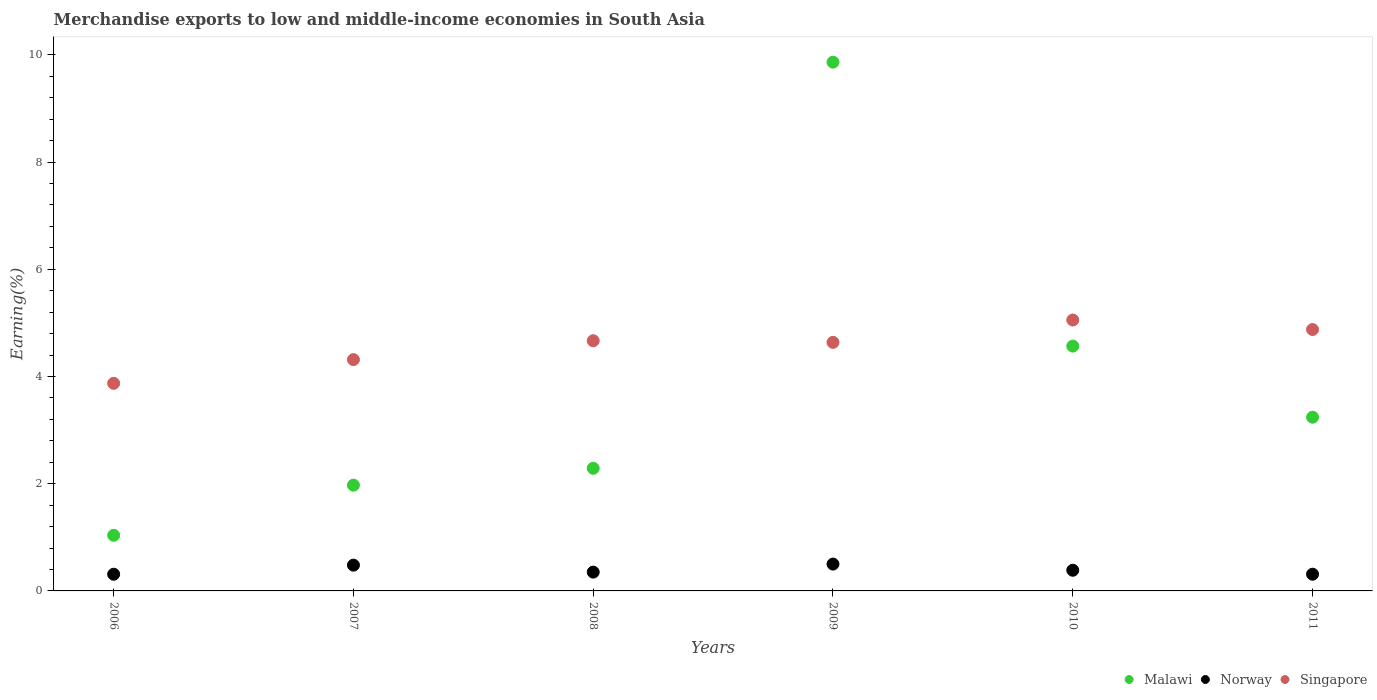How many different coloured dotlines are there?
Offer a terse response. 3. Is the number of dotlines equal to the number of legend labels?
Give a very brief answer. Yes. What is the percentage of amount earned from merchandise exports in Norway in 2008?
Offer a very short reply. 0.35. Across all years, what is the maximum percentage of amount earned from merchandise exports in Malawi?
Offer a very short reply. 9.86. Across all years, what is the minimum percentage of amount earned from merchandise exports in Malawi?
Give a very brief answer. 1.04. In which year was the percentage of amount earned from merchandise exports in Norway maximum?
Keep it short and to the point. 2009. In which year was the percentage of amount earned from merchandise exports in Malawi minimum?
Your answer should be compact. 2006. What is the total percentage of amount earned from merchandise exports in Singapore in the graph?
Provide a short and direct response. 27.42. What is the difference between the percentage of amount earned from merchandise exports in Malawi in 2006 and that in 2007?
Ensure brevity in your answer.  -0.94. What is the difference between the percentage of amount earned from merchandise exports in Malawi in 2009 and the percentage of amount earned from merchandise exports in Singapore in 2007?
Provide a short and direct response. 5.55. What is the average percentage of amount earned from merchandise exports in Norway per year?
Offer a terse response. 0.39. In the year 2006, what is the difference between the percentage of amount earned from merchandise exports in Singapore and percentage of amount earned from merchandise exports in Malawi?
Your answer should be compact. 2.83. What is the ratio of the percentage of amount earned from merchandise exports in Singapore in 2007 to that in 2009?
Provide a succinct answer. 0.93. Is the difference between the percentage of amount earned from merchandise exports in Singapore in 2010 and 2011 greater than the difference between the percentage of amount earned from merchandise exports in Malawi in 2010 and 2011?
Your answer should be very brief. No. What is the difference between the highest and the second highest percentage of amount earned from merchandise exports in Norway?
Your answer should be very brief. 0.02. What is the difference between the highest and the lowest percentage of amount earned from merchandise exports in Norway?
Ensure brevity in your answer.  0.19. Is the sum of the percentage of amount earned from merchandise exports in Singapore in 2007 and 2008 greater than the maximum percentage of amount earned from merchandise exports in Norway across all years?
Offer a very short reply. Yes. Is the percentage of amount earned from merchandise exports in Norway strictly greater than the percentage of amount earned from merchandise exports in Malawi over the years?
Keep it short and to the point. No. Is the percentage of amount earned from merchandise exports in Singapore strictly less than the percentage of amount earned from merchandise exports in Norway over the years?
Ensure brevity in your answer.  No. How many years are there in the graph?
Provide a short and direct response. 6. Does the graph contain grids?
Make the answer very short. No. Where does the legend appear in the graph?
Your answer should be very brief. Bottom right. What is the title of the graph?
Provide a succinct answer. Merchandise exports to low and middle-income economies in South Asia. Does "Liberia" appear as one of the legend labels in the graph?
Your response must be concise. No. What is the label or title of the X-axis?
Your answer should be compact. Years. What is the label or title of the Y-axis?
Provide a succinct answer. Earning(%). What is the Earning(%) of Malawi in 2006?
Your answer should be compact. 1.04. What is the Earning(%) of Norway in 2006?
Your response must be concise. 0.31. What is the Earning(%) of Singapore in 2006?
Your response must be concise. 3.87. What is the Earning(%) of Malawi in 2007?
Your answer should be very brief. 1.97. What is the Earning(%) in Norway in 2007?
Offer a very short reply. 0.48. What is the Earning(%) of Singapore in 2007?
Make the answer very short. 4.31. What is the Earning(%) in Malawi in 2008?
Ensure brevity in your answer.  2.29. What is the Earning(%) of Norway in 2008?
Provide a succinct answer. 0.35. What is the Earning(%) of Singapore in 2008?
Make the answer very short. 4.67. What is the Earning(%) of Malawi in 2009?
Provide a succinct answer. 9.86. What is the Earning(%) in Norway in 2009?
Ensure brevity in your answer.  0.5. What is the Earning(%) in Singapore in 2009?
Provide a short and direct response. 4.64. What is the Earning(%) in Malawi in 2010?
Offer a very short reply. 4.57. What is the Earning(%) of Norway in 2010?
Offer a very short reply. 0.39. What is the Earning(%) in Singapore in 2010?
Provide a short and direct response. 5.05. What is the Earning(%) in Malawi in 2011?
Your response must be concise. 3.24. What is the Earning(%) in Norway in 2011?
Your answer should be compact. 0.31. What is the Earning(%) of Singapore in 2011?
Your answer should be compact. 4.88. Across all years, what is the maximum Earning(%) in Malawi?
Ensure brevity in your answer.  9.86. Across all years, what is the maximum Earning(%) of Norway?
Offer a terse response. 0.5. Across all years, what is the maximum Earning(%) in Singapore?
Offer a very short reply. 5.05. Across all years, what is the minimum Earning(%) of Malawi?
Your answer should be compact. 1.04. Across all years, what is the minimum Earning(%) of Norway?
Ensure brevity in your answer.  0.31. Across all years, what is the minimum Earning(%) of Singapore?
Provide a succinct answer. 3.87. What is the total Earning(%) of Malawi in the graph?
Give a very brief answer. 22.97. What is the total Earning(%) of Norway in the graph?
Your response must be concise. 2.34. What is the total Earning(%) in Singapore in the graph?
Make the answer very short. 27.42. What is the difference between the Earning(%) of Malawi in 2006 and that in 2007?
Make the answer very short. -0.94. What is the difference between the Earning(%) of Norway in 2006 and that in 2007?
Ensure brevity in your answer.  -0.17. What is the difference between the Earning(%) in Singapore in 2006 and that in 2007?
Your answer should be very brief. -0.44. What is the difference between the Earning(%) in Malawi in 2006 and that in 2008?
Your answer should be compact. -1.25. What is the difference between the Earning(%) of Norway in 2006 and that in 2008?
Your response must be concise. -0.04. What is the difference between the Earning(%) of Singapore in 2006 and that in 2008?
Your answer should be compact. -0.79. What is the difference between the Earning(%) in Malawi in 2006 and that in 2009?
Provide a succinct answer. -8.82. What is the difference between the Earning(%) of Norway in 2006 and that in 2009?
Offer a terse response. -0.19. What is the difference between the Earning(%) in Singapore in 2006 and that in 2009?
Provide a short and direct response. -0.76. What is the difference between the Earning(%) of Malawi in 2006 and that in 2010?
Your answer should be very brief. -3.53. What is the difference between the Earning(%) in Norway in 2006 and that in 2010?
Provide a succinct answer. -0.07. What is the difference between the Earning(%) in Singapore in 2006 and that in 2010?
Ensure brevity in your answer.  -1.18. What is the difference between the Earning(%) in Malawi in 2006 and that in 2011?
Offer a terse response. -2.2. What is the difference between the Earning(%) in Norway in 2006 and that in 2011?
Keep it short and to the point. -0. What is the difference between the Earning(%) of Singapore in 2006 and that in 2011?
Your answer should be very brief. -1. What is the difference between the Earning(%) in Malawi in 2007 and that in 2008?
Offer a very short reply. -0.31. What is the difference between the Earning(%) in Norway in 2007 and that in 2008?
Give a very brief answer. 0.13. What is the difference between the Earning(%) in Singapore in 2007 and that in 2008?
Your answer should be very brief. -0.35. What is the difference between the Earning(%) in Malawi in 2007 and that in 2009?
Offer a very short reply. -7.89. What is the difference between the Earning(%) in Norway in 2007 and that in 2009?
Keep it short and to the point. -0.02. What is the difference between the Earning(%) in Singapore in 2007 and that in 2009?
Keep it short and to the point. -0.32. What is the difference between the Earning(%) of Malawi in 2007 and that in 2010?
Your answer should be very brief. -2.59. What is the difference between the Earning(%) in Norway in 2007 and that in 2010?
Offer a very short reply. 0.1. What is the difference between the Earning(%) of Singapore in 2007 and that in 2010?
Provide a succinct answer. -0.74. What is the difference between the Earning(%) in Malawi in 2007 and that in 2011?
Your answer should be very brief. -1.27. What is the difference between the Earning(%) of Norway in 2007 and that in 2011?
Your answer should be very brief. 0.17. What is the difference between the Earning(%) of Singapore in 2007 and that in 2011?
Make the answer very short. -0.56. What is the difference between the Earning(%) of Malawi in 2008 and that in 2009?
Provide a short and direct response. -7.57. What is the difference between the Earning(%) of Norway in 2008 and that in 2009?
Make the answer very short. -0.15. What is the difference between the Earning(%) in Singapore in 2008 and that in 2009?
Offer a very short reply. 0.03. What is the difference between the Earning(%) in Malawi in 2008 and that in 2010?
Provide a short and direct response. -2.28. What is the difference between the Earning(%) in Norway in 2008 and that in 2010?
Keep it short and to the point. -0.03. What is the difference between the Earning(%) of Singapore in 2008 and that in 2010?
Give a very brief answer. -0.39. What is the difference between the Earning(%) in Malawi in 2008 and that in 2011?
Your answer should be compact. -0.95. What is the difference between the Earning(%) of Norway in 2008 and that in 2011?
Your response must be concise. 0.04. What is the difference between the Earning(%) in Singapore in 2008 and that in 2011?
Offer a terse response. -0.21. What is the difference between the Earning(%) of Malawi in 2009 and that in 2010?
Offer a very short reply. 5.3. What is the difference between the Earning(%) in Norway in 2009 and that in 2010?
Offer a terse response. 0.12. What is the difference between the Earning(%) of Singapore in 2009 and that in 2010?
Provide a short and direct response. -0.42. What is the difference between the Earning(%) in Malawi in 2009 and that in 2011?
Keep it short and to the point. 6.62. What is the difference between the Earning(%) in Norway in 2009 and that in 2011?
Provide a short and direct response. 0.19. What is the difference between the Earning(%) of Singapore in 2009 and that in 2011?
Your answer should be compact. -0.24. What is the difference between the Earning(%) in Malawi in 2010 and that in 2011?
Offer a terse response. 1.33. What is the difference between the Earning(%) in Norway in 2010 and that in 2011?
Offer a terse response. 0.07. What is the difference between the Earning(%) of Singapore in 2010 and that in 2011?
Your answer should be very brief. 0.18. What is the difference between the Earning(%) of Malawi in 2006 and the Earning(%) of Norway in 2007?
Provide a succinct answer. 0.56. What is the difference between the Earning(%) in Malawi in 2006 and the Earning(%) in Singapore in 2007?
Your answer should be compact. -3.28. What is the difference between the Earning(%) in Norway in 2006 and the Earning(%) in Singapore in 2007?
Make the answer very short. -4. What is the difference between the Earning(%) of Malawi in 2006 and the Earning(%) of Norway in 2008?
Provide a short and direct response. 0.69. What is the difference between the Earning(%) of Malawi in 2006 and the Earning(%) of Singapore in 2008?
Keep it short and to the point. -3.63. What is the difference between the Earning(%) of Norway in 2006 and the Earning(%) of Singapore in 2008?
Your answer should be compact. -4.36. What is the difference between the Earning(%) in Malawi in 2006 and the Earning(%) in Norway in 2009?
Keep it short and to the point. 0.54. What is the difference between the Earning(%) in Malawi in 2006 and the Earning(%) in Singapore in 2009?
Make the answer very short. -3.6. What is the difference between the Earning(%) of Norway in 2006 and the Earning(%) of Singapore in 2009?
Ensure brevity in your answer.  -4.32. What is the difference between the Earning(%) in Malawi in 2006 and the Earning(%) in Norway in 2010?
Offer a terse response. 0.65. What is the difference between the Earning(%) in Malawi in 2006 and the Earning(%) in Singapore in 2010?
Offer a terse response. -4.02. What is the difference between the Earning(%) of Norway in 2006 and the Earning(%) of Singapore in 2010?
Make the answer very short. -4.74. What is the difference between the Earning(%) in Malawi in 2006 and the Earning(%) in Norway in 2011?
Keep it short and to the point. 0.73. What is the difference between the Earning(%) in Malawi in 2006 and the Earning(%) in Singapore in 2011?
Your answer should be very brief. -3.84. What is the difference between the Earning(%) in Norway in 2006 and the Earning(%) in Singapore in 2011?
Provide a short and direct response. -4.56. What is the difference between the Earning(%) in Malawi in 2007 and the Earning(%) in Norway in 2008?
Ensure brevity in your answer.  1.62. What is the difference between the Earning(%) in Malawi in 2007 and the Earning(%) in Singapore in 2008?
Your answer should be compact. -2.69. What is the difference between the Earning(%) of Norway in 2007 and the Earning(%) of Singapore in 2008?
Your answer should be very brief. -4.19. What is the difference between the Earning(%) of Malawi in 2007 and the Earning(%) of Norway in 2009?
Make the answer very short. 1.47. What is the difference between the Earning(%) in Malawi in 2007 and the Earning(%) in Singapore in 2009?
Ensure brevity in your answer.  -2.66. What is the difference between the Earning(%) of Norway in 2007 and the Earning(%) of Singapore in 2009?
Make the answer very short. -4.16. What is the difference between the Earning(%) of Malawi in 2007 and the Earning(%) of Norway in 2010?
Your answer should be very brief. 1.59. What is the difference between the Earning(%) of Malawi in 2007 and the Earning(%) of Singapore in 2010?
Your answer should be compact. -3.08. What is the difference between the Earning(%) in Norway in 2007 and the Earning(%) in Singapore in 2010?
Provide a short and direct response. -4.57. What is the difference between the Earning(%) in Malawi in 2007 and the Earning(%) in Norway in 2011?
Make the answer very short. 1.66. What is the difference between the Earning(%) of Malawi in 2007 and the Earning(%) of Singapore in 2011?
Ensure brevity in your answer.  -2.9. What is the difference between the Earning(%) in Norway in 2007 and the Earning(%) in Singapore in 2011?
Make the answer very short. -4.39. What is the difference between the Earning(%) in Malawi in 2008 and the Earning(%) in Norway in 2009?
Offer a very short reply. 1.79. What is the difference between the Earning(%) in Malawi in 2008 and the Earning(%) in Singapore in 2009?
Give a very brief answer. -2.35. What is the difference between the Earning(%) of Norway in 2008 and the Earning(%) of Singapore in 2009?
Provide a succinct answer. -4.29. What is the difference between the Earning(%) in Malawi in 2008 and the Earning(%) in Norway in 2010?
Ensure brevity in your answer.  1.9. What is the difference between the Earning(%) in Malawi in 2008 and the Earning(%) in Singapore in 2010?
Keep it short and to the point. -2.77. What is the difference between the Earning(%) in Norway in 2008 and the Earning(%) in Singapore in 2010?
Keep it short and to the point. -4.7. What is the difference between the Earning(%) in Malawi in 2008 and the Earning(%) in Norway in 2011?
Provide a short and direct response. 1.98. What is the difference between the Earning(%) in Malawi in 2008 and the Earning(%) in Singapore in 2011?
Offer a very short reply. -2.59. What is the difference between the Earning(%) in Norway in 2008 and the Earning(%) in Singapore in 2011?
Your answer should be compact. -4.52. What is the difference between the Earning(%) in Malawi in 2009 and the Earning(%) in Norway in 2010?
Your answer should be compact. 9.48. What is the difference between the Earning(%) in Malawi in 2009 and the Earning(%) in Singapore in 2010?
Your answer should be compact. 4.81. What is the difference between the Earning(%) in Norway in 2009 and the Earning(%) in Singapore in 2010?
Make the answer very short. -4.55. What is the difference between the Earning(%) of Malawi in 2009 and the Earning(%) of Norway in 2011?
Your response must be concise. 9.55. What is the difference between the Earning(%) in Malawi in 2009 and the Earning(%) in Singapore in 2011?
Offer a very short reply. 4.99. What is the difference between the Earning(%) of Norway in 2009 and the Earning(%) of Singapore in 2011?
Provide a succinct answer. -4.37. What is the difference between the Earning(%) in Malawi in 2010 and the Earning(%) in Norway in 2011?
Your answer should be very brief. 4.25. What is the difference between the Earning(%) of Malawi in 2010 and the Earning(%) of Singapore in 2011?
Ensure brevity in your answer.  -0.31. What is the difference between the Earning(%) in Norway in 2010 and the Earning(%) in Singapore in 2011?
Offer a very short reply. -4.49. What is the average Earning(%) of Malawi per year?
Offer a terse response. 3.83. What is the average Earning(%) of Norway per year?
Make the answer very short. 0.39. What is the average Earning(%) of Singapore per year?
Provide a short and direct response. 4.57. In the year 2006, what is the difference between the Earning(%) in Malawi and Earning(%) in Norway?
Offer a very short reply. 0.73. In the year 2006, what is the difference between the Earning(%) of Malawi and Earning(%) of Singapore?
Keep it short and to the point. -2.83. In the year 2006, what is the difference between the Earning(%) in Norway and Earning(%) in Singapore?
Your answer should be very brief. -3.56. In the year 2007, what is the difference between the Earning(%) of Malawi and Earning(%) of Norway?
Your answer should be very brief. 1.49. In the year 2007, what is the difference between the Earning(%) in Malawi and Earning(%) in Singapore?
Your answer should be compact. -2.34. In the year 2007, what is the difference between the Earning(%) in Norway and Earning(%) in Singapore?
Your response must be concise. -3.83. In the year 2008, what is the difference between the Earning(%) of Malawi and Earning(%) of Norway?
Make the answer very short. 1.94. In the year 2008, what is the difference between the Earning(%) in Malawi and Earning(%) in Singapore?
Give a very brief answer. -2.38. In the year 2008, what is the difference between the Earning(%) in Norway and Earning(%) in Singapore?
Ensure brevity in your answer.  -4.32. In the year 2009, what is the difference between the Earning(%) in Malawi and Earning(%) in Norway?
Offer a very short reply. 9.36. In the year 2009, what is the difference between the Earning(%) of Malawi and Earning(%) of Singapore?
Keep it short and to the point. 5.23. In the year 2009, what is the difference between the Earning(%) in Norway and Earning(%) in Singapore?
Give a very brief answer. -4.14. In the year 2010, what is the difference between the Earning(%) of Malawi and Earning(%) of Norway?
Your answer should be compact. 4.18. In the year 2010, what is the difference between the Earning(%) of Malawi and Earning(%) of Singapore?
Your response must be concise. -0.49. In the year 2010, what is the difference between the Earning(%) in Norway and Earning(%) in Singapore?
Offer a very short reply. -4.67. In the year 2011, what is the difference between the Earning(%) of Malawi and Earning(%) of Norway?
Offer a very short reply. 2.93. In the year 2011, what is the difference between the Earning(%) of Malawi and Earning(%) of Singapore?
Provide a succinct answer. -1.64. In the year 2011, what is the difference between the Earning(%) in Norway and Earning(%) in Singapore?
Keep it short and to the point. -4.56. What is the ratio of the Earning(%) in Malawi in 2006 to that in 2007?
Your response must be concise. 0.53. What is the ratio of the Earning(%) of Norway in 2006 to that in 2007?
Keep it short and to the point. 0.65. What is the ratio of the Earning(%) of Singapore in 2006 to that in 2007?
Provide a short and direct response. 0.9. What is the ratio of the Earning(%) in Malawi in 2006 to that in 2008?
Keep it short and to the point. 0.45. What is the ratio of the Earning(%) in Norway in 2006 to that in 2008?
Ensure brevity in your answer.  0.89. What is the ratio of the Earning(%) in Singapore in 2006 to that in 2008?
Make the answer very short. 0.83. What is the ratio of the Earning(%) of Malawi in 2006 to that in 2009?
Your answer should be compact. 0.11. What is the ratio of the Earning(%) of Norway in 2006 to that in 2009?
Offer a very short reply. 0.62. What is the ratio of the Earning(%) in Singapore in 2006 to that in 2009?
Give a very brief answer. 0.84. What is the ratio of the Earning(%) in Malawi in 2006 to that in 2010?
Your answer should be compact. 0.23. What is the ratio of the Earning(%) of Norway in 2006 to that in 2010?
Your response must be concise. 0.81. What is the ratio of the Earning(%) of Singapore in 2006 to that in 2010?
Offer a very short reply. 0.77. What is the ratio of the Earning(%) of Malawi in 2006 to that in 2011?
Provide a short and direct response. 0.32. What is the ratio of the Earning(%) in Singapore in 2006 to that in 2011?
Provide a succinct answer. 0.79. What is the ratio of the Earning(%) of Malawi in 2007 to that in 2008?
Ensure brevity in your answer.  0.86. What is the ratio of the Earning(%) of Norway in 2007 to that in 2008?
Your answer should be very brief. 1.37. What is the ratio of the Earning(%) in Singapore in 2007 to that in 2008?
Ensure brevity in your answer.  0.92. What is the ratio of the Earning(%) of Malawi in 2007 to that in 2009?
Offer a very short reply. 0.2. What is the ratio of the Earning(%) in Norway in 2007 to that in 2009?
Your answer should be compact. 0.96. What is the ratio of the Earning(%) of Singapore in 2007 to that in 2009?
Your answer should be compact. 0.93. What is the ratio of the Earning(%) of Malawi in 2007 to that in 2010?
Make the answer very short. 0.43. What is the ratio of the Earning(%) in Norway in 2007 to that in 2010?
Give a very brief answer. 1.25. What is the ratio of the Earning(%) of Singapore in 2007 to that in 2010?
Provide a succinct answer. 0.85. What is the ratio of the Earning(%) of Malawi in 2007 to that in 2011?
Offer a terse response. 0.61. What is the ratio of the Earning(%) in Norway in 2007 to that in 2011?
Provide a succinct answer. 1.54. What is the ratio of the Earning(%) of Singapore in 2007 to that in 2011?
Keep it short and to the point. 0.88. What is the ratio of the Earning(%) of Malawi in 2008 to that in 2009?
Make the answer very short. 0.23. What is the ratio of the Earning(%) of Norway in 2008 to that in 2009?
Give a very brief answer. 0.7. What is the ratio of the Earning(%) in Singapore in 2008 to that in 2009?
Keep it short and to the point. 1.01. What is the ratio of the Earning(%) of Malawi in 2008 to that in 2010?
Your answer should be compact. 0.5. What is the ratio of the Earning(%) in Norway in 2008 to that in 2010?
Make the answer very short. 0.91. What is the ratio of the Earning(%) in Singapore in 2008 to that in 2010?
Keep it short and to the point. 0.92. What is the ratio of the Earning(%) in Malawi in 2008 to that in 2011?
Provide a succinct answer. 0.71. What is the ratio of the Earning(%) in Norway in 2008 to that in 2011?
Your answer should be compact. 1.12. What is the ratio of the Earning(%) of Singapore in 2008 to that in 2011?
Ensure brevity in your answer.  0.96. What is the ratio of the Earning(%) of Malawi in 2009 to that in 2010?
Give a very brief answer. 2.16. What is the ratio of the Earning(%) of Norway in 2009 to that in 2010?
Offer a terse response. 1.3. What is the ratio of the Earning(%) in Singapore in 2009 to that in 2010?
Your response must be concise. 0.92. What is the ratio of the Earning(%) of Malawi in 2009 to that in 2011?
Keep it short and to the point. 3.04. What is the ratio of the Earning(%) in Norway in 2009 to that in 2011?
Keep it short and to the point. 1.61. What is the ratio of the Earning(%) in Singapore in 2009 to that in 2011?
Your answer should be very brief. 0.95. What is the ratio of the Earning(%) of Malawi in 2010 to that in 2011?
Provide a short and direct response. 1.41. What is the ratio of the Earning(%) of Norway in 2010 to that in 2011?
Your response must be concise. 1.24. What is the ratio of the Earning(%) in Singapore in 2010 to that in 2011?
Your response must be concise. 1.04. What is the difference between the highest and the second highest Earning(%) of Malawi?
Provide a short and direct response. 5.3. What is the difference between the highest and the second highest Earning(%) in Norway?
Ensure brevity in your answer.  0.02. What is the difference between the highest and the second highest Earning(%) in Singapore?
Your answer should be compact. 0.18. What is the difference between the highest and the lowest Earning(%) of Malawi?
Offer a terse response. 8.82. What is the difference between the highest and the lowest Earning(%) in Norway?
Keep it short and to the point. 0.19. What is the difference between the highest and the lowest Earning(%) in Singapore?
Your response must be concise. 1.18. 